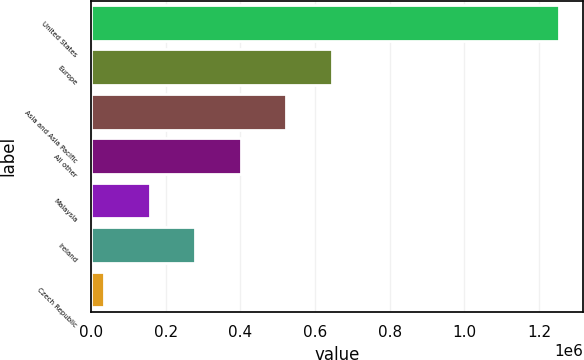<chart> <loc_0><loc_0><loc_500><loc_500><bar_chart><fcel>United States<fcel>Europe<fcel>Asia and Asia Pacific<fcel>All other<fcel>Malaysia<fcel>Ireland<fcel>Czech Republic<nl><fcel>1.25482e+06<fcel>645270<fcel>523359<fcel>401448<fcel>157626<fcel>279537<fcel>35715<nl></chart> 